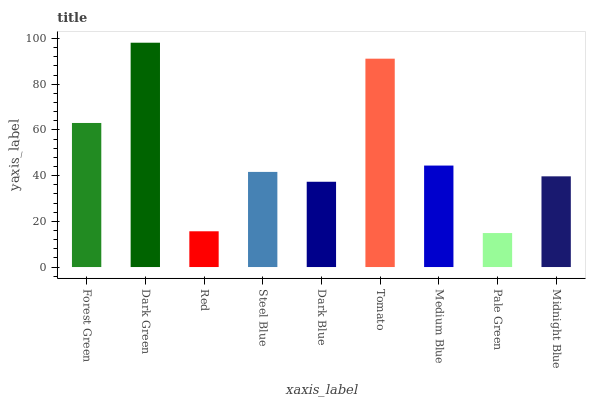Is Pale Green the minimum?
Answer yes or no. Yes. Is Dark Green the maximum?
Answer yes or no. Yes. Is Red the minimum?
Answer yes or no. No. Is Red the maximum?
Answer yes or no. No. Is Dark Green greater than Red?
Answer yes or no. Yes. Is Red less than Dark Green?
Answer yes or no. Yes. Is Red greater than Dark Green?
Answer yes or no. No. Is Dark Green less than Red?
Answer yes or no. No. Is Steel Blue the high median?
Answer yes or no. Yes. Is Steel Blue the low median?
Answer yes or no. Yes. Is Forest Green the high median?
Answer yes or no. No. Is Dark Green the low median?
Answer yes or no. No. 